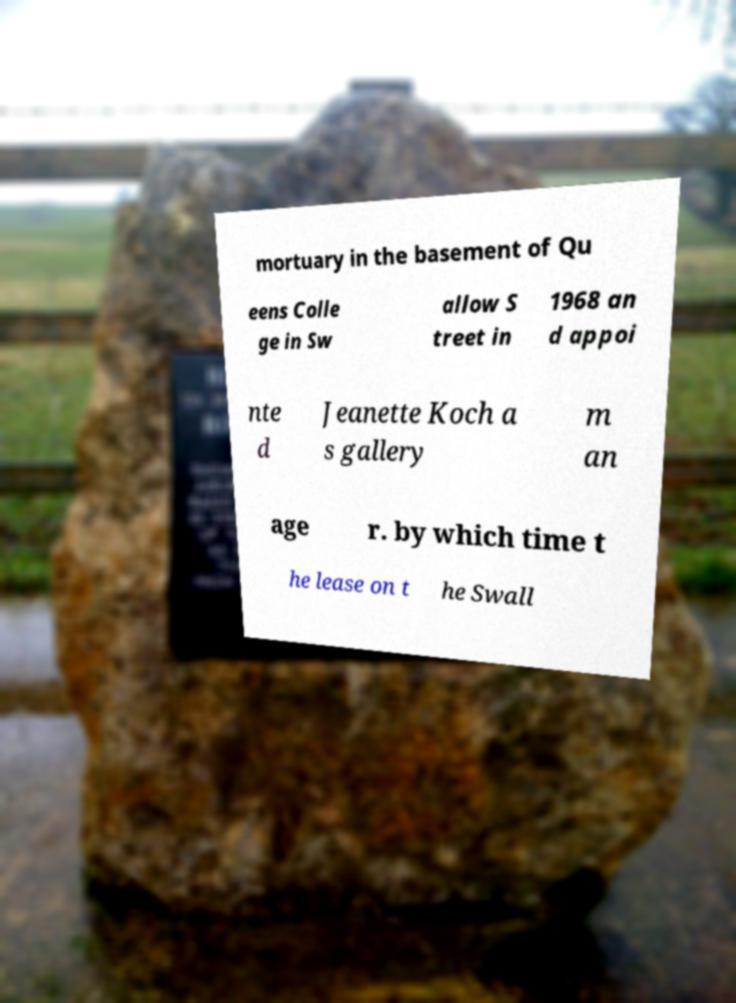Please read and relay the text visible in this image. What does it say? mortuary in the basement of Qu eens Colle ge in Sw allow S treet in 1968 an d appoi nte d Jeanette Koch a s gallery m an age r. by which time t he lease on t he Swall 